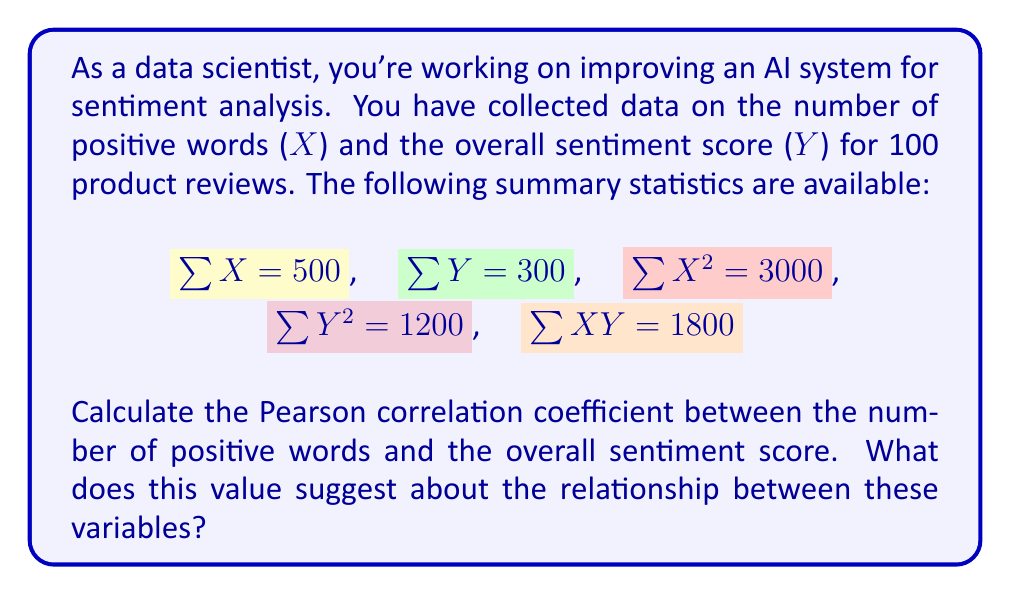What is the answer to this math problem? To calculate the Pearson correlation coefficient ($r$), we'll use the formula:

$$r = \frac{n\sum XY - \sum X \sum Y}{\sqrt{[n\sum X^2 - (\sum X)^2][n\sum Y^2 - (\sum Y)^2]}}$$

Where $n$ is the number of data points (100 in this case).

Let's substitute the given values:

$$r = \frac{100(1800) - (500)(300)}{\sqrt{[100(3000) - (500)^2][100(1200) - (300)^2]}}$$

Step 1: Calculate the numerator
$100(1800) - (500)(300) = 180000 - 150000 = 30000$

Step 2: Calculate the first part under the square root
$100(3000) - (500)^2 = 300000 - 250000 = 50000$

Step 3: Calculate the second part under the square root
$100(1200) - (300)^2 = 120000 - 90000 = 30000$

Step 4: Multiply the parts under the square root
$50000 * 30000 = 1500000000$

Step 5: Take the square root of the product
$\sqrt{1500000000} = 38729.83$

Step 6: Divide the numerator by the denominator
$r = \frac{30000}{38729.83} \approx 0.7746$

The Pearson correlation coefficient is approximately 0.7746.

This value suggests a strong positive correlation between the number of positive words and the overall sentiment score. In the context of improving an AI system for sentiment analysis, this indicates that the number of positive words is a good predictor of the overall sentiment score, which could be a valuable feature for the AI model.
Answer: $r \approx 0.7746$ 